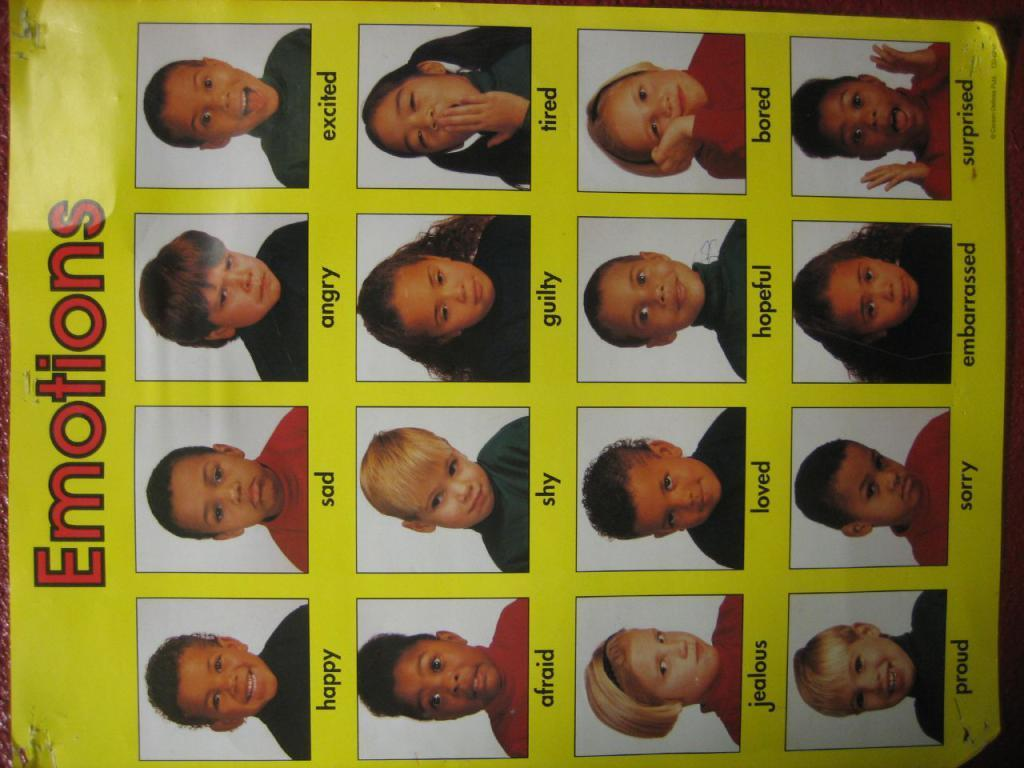What is the main subject of the image? The main subject of the image is a chart. What type of content is included in the chart? The chart contains images of persons. Is there any additional information provided with the chart? Yes, there is text associated with the chart. What type of precipitation is falling in the image? There is no precipitation present in the image; it features a chart with images of persons and associated text. 